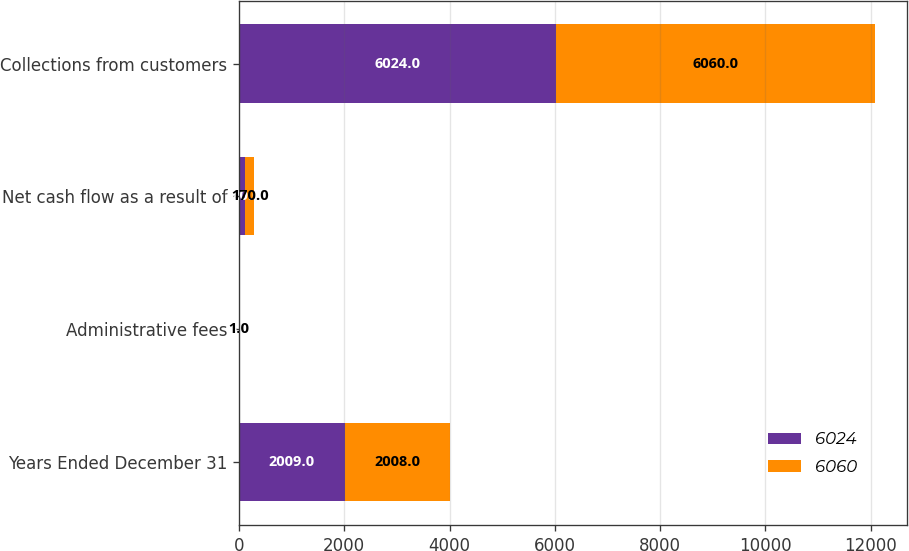Convert chart to OTSL. <chart><loc_0><loc_0><loc_500><loc_500><stacked_bar_chart><ecel><fcel>Years Ended December 31<fcel>Administrative fees<fcel>Net cash flow as a result of<fcel>Collections from customers<nl><fcel>6024<fcel>2009<fcel>3<fcel>120<fcel>6024<nl><fcel>6060<fcel>2008<fcel>1<fcel>170<fcel>6060<nl></chart> 